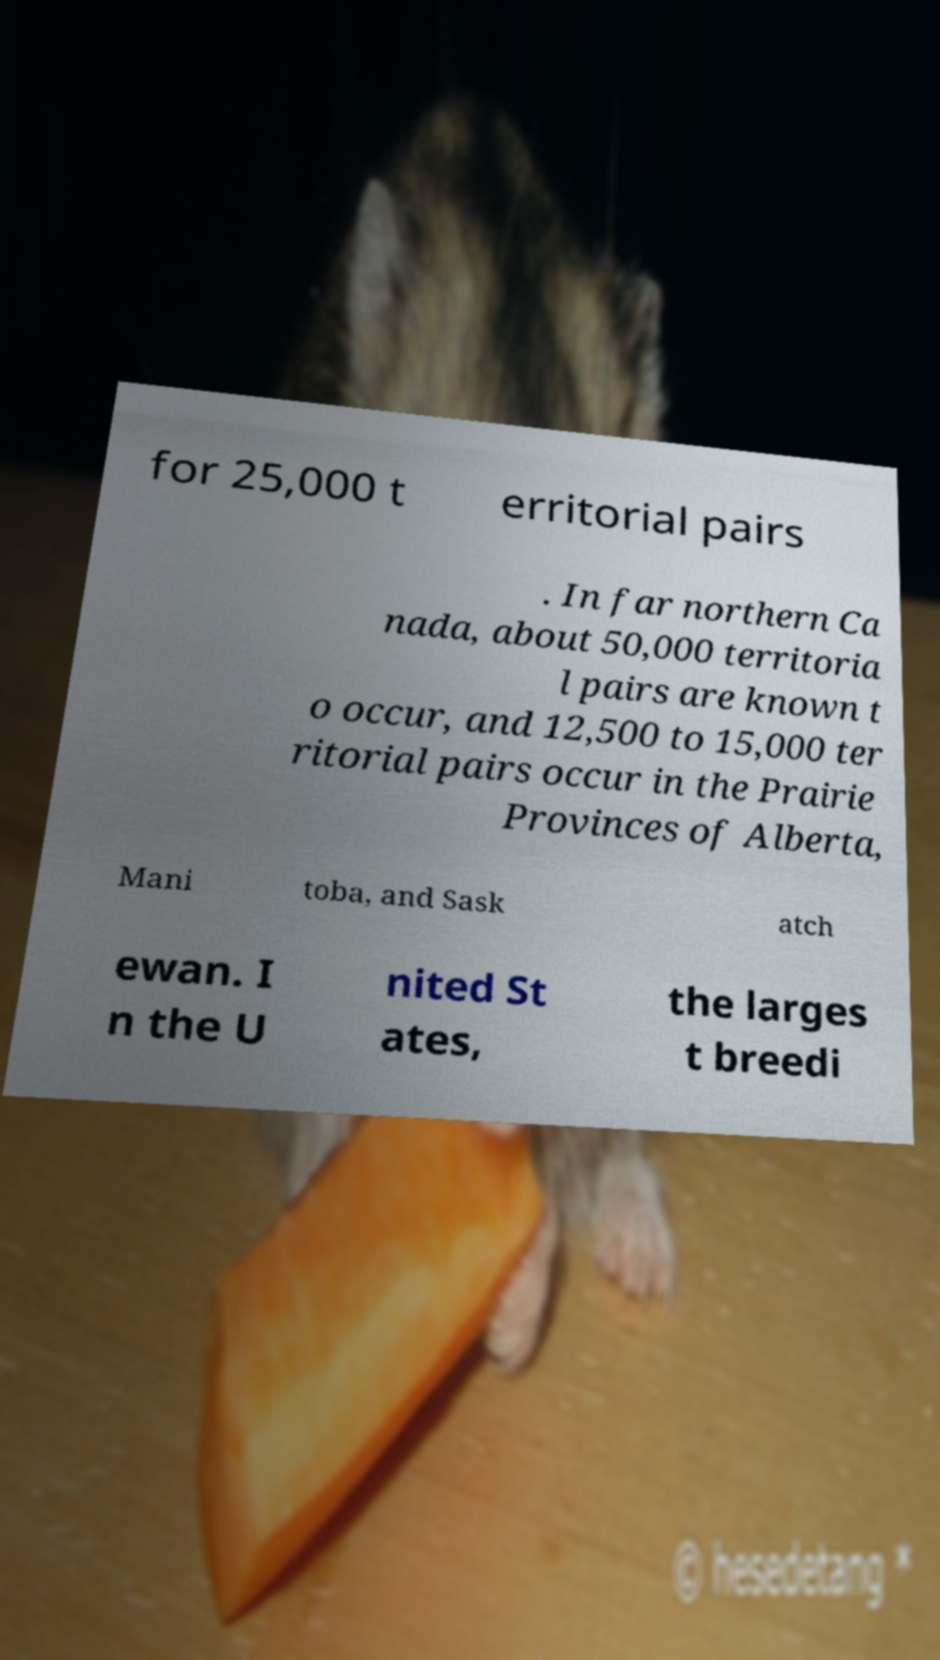For documentation purposes, I need the text within this image transcribed. Could you provide that? for 25,000 t erritorial pairs . In far northern Ca nada, about 50,000 territoria l pairs are known t o occur, and 12,500 to 15,000 ter ritorial pairs occur in the Prairie Provinces of Alberta, Mani toba, and Sask atch ewan. I n the U nited St ates, the larges t breedi 